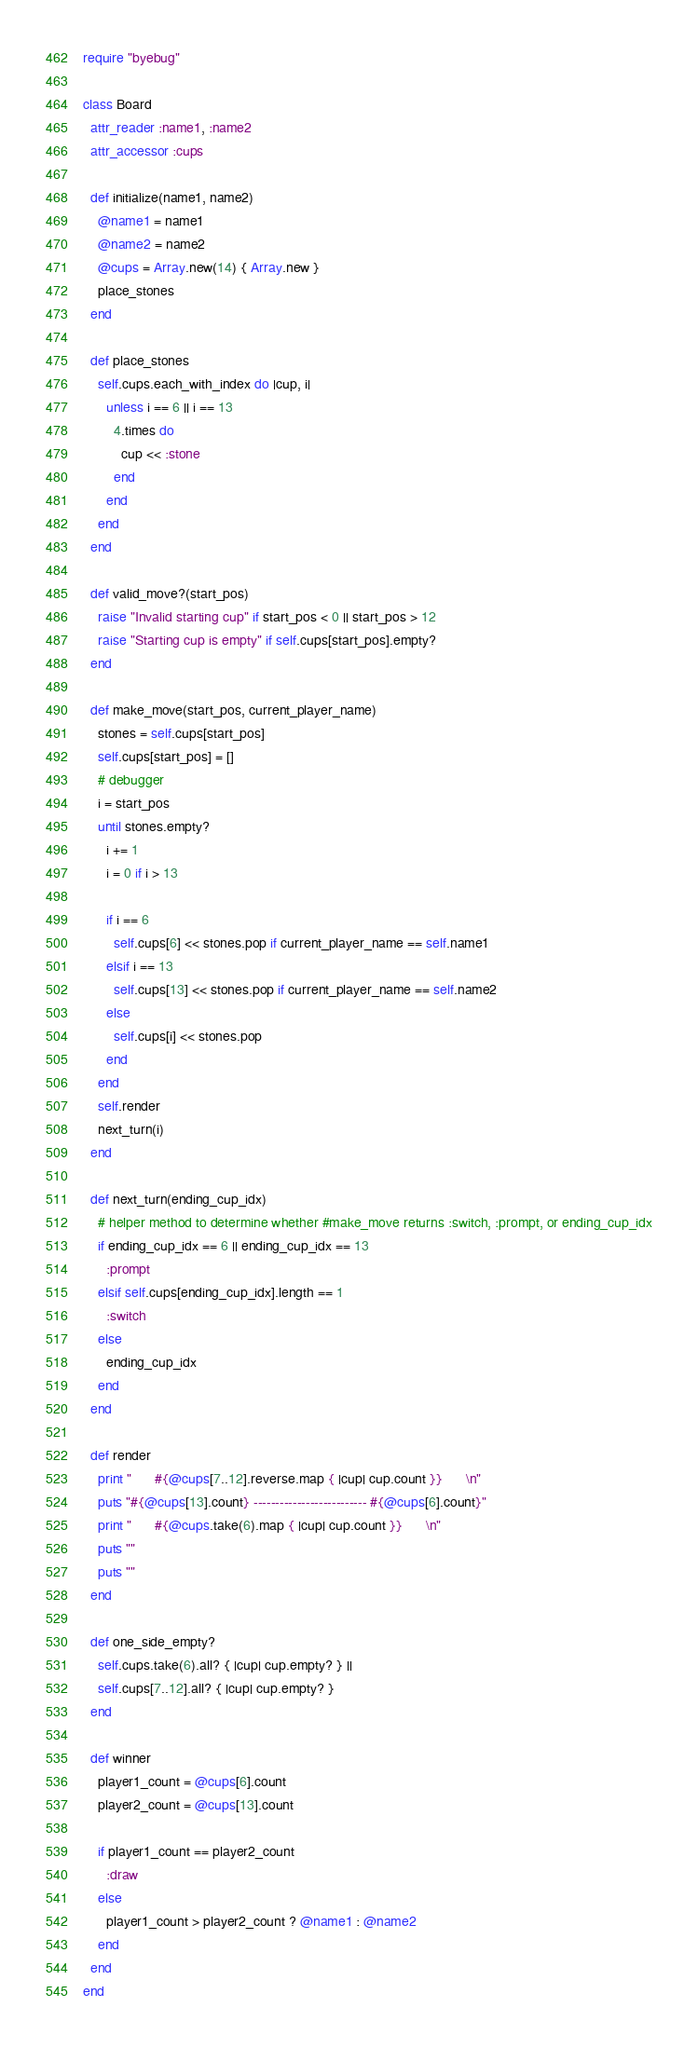<code> <loc_0><loc_0><loc_500><loc_500><_Ruby_>require "byebug"

class Board
  attr_reader :name1, :name2
  attr_accessor :cups

  def initialize(name1, name2)
    @name1 = name1
    @name2 = name2
    @cups = Array.new(14) { Array.new }
    place_stones
  end

  def place_stones
    self.cups.each_with_index do |cup, i|
      unless i == 6 || i == 13
        4.times do
          cup << :stone
        end
      end
    end
  end

  def valid_move?(start_pos)
    raise "Invalid starting cup" if start_pos < 0 || start_pos > 12
    raise "Starting cup is empty" if self.cups[start_pos].empty?
  end

  def make_move(start_pos, current_player_name)
    stones = self.cups[start_pos]
    self.cups[start_pos] = []
    # debugger
    i = start_pos
    until stones.empty?
      i += 1
      i = 0 if i > 13

      if i == 6
        self.cups[6] << stones.pop if current_player_name == self.name1
      elsif i == 13
        self.cups[13] << stones.pop if current_player_name == self.name2
      else
        self.cups[i] << stones.pop
      end
    end
    self.render
    next_turn(i)
  end

  def next_turn(ending_cup_idx)
    # helper method to determine whether #make_move returns :switch, :prompt, or ending_cup_idx
    if ending_cup_idx == 6 || ending_cup_idx == 13
      :prompt
    elsif self.cups[ending_cup_idx].length == 1
      :switch
    else
      ending_cup_idx
    end
  end

  def render
    print "      #{@cups[7..12].reverse.map { |cup| cup.count }}      \n"
    puts "#{@cups[13].count} -------------------------- #{@cups[6].count}"
    print "      #{@cups.take(6).map { |cup| cup.count }}      \n"
    puts ""
    puts ""
  end

  def one_side_empty?
    self.cups.take(6).all? { |cup| cup.empty? } ||
    self.cups[7..12].all? { |cup| cup.empty? }
  end

  def winner
    player1_count = @cups[6].count
    player2_count = @cups[13].count

    if player1_count == player2_count
      :draw
    else
      player1_count > player2_count ? @name1 : @name2
    end
  end
end
</code> 